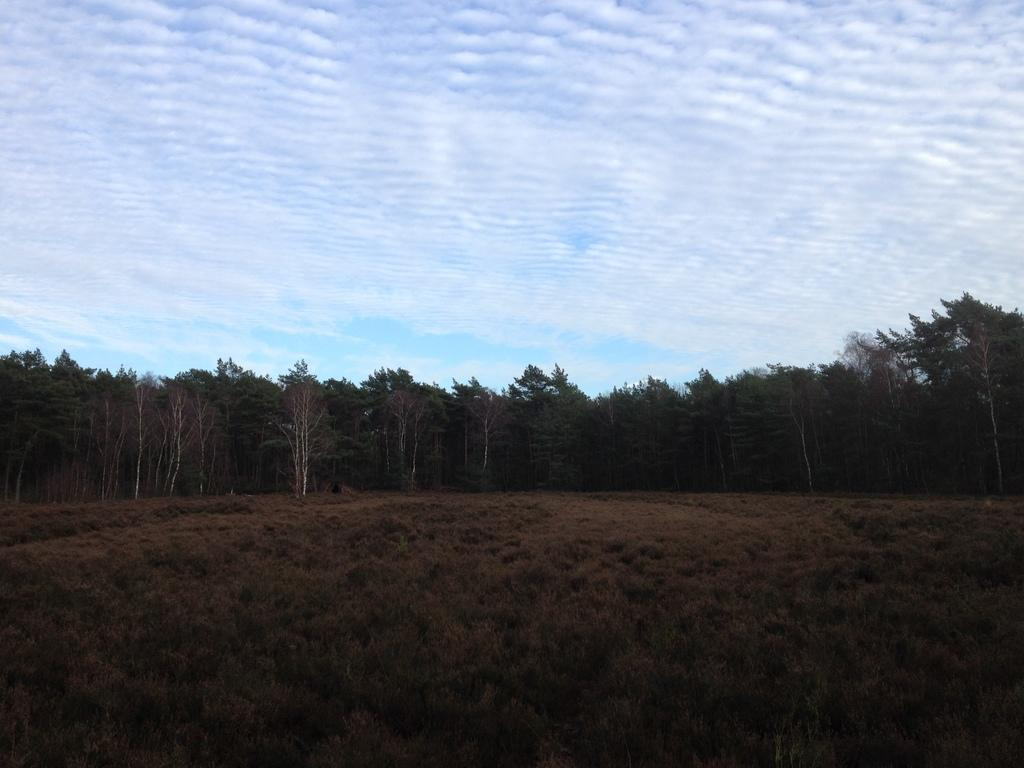What type of vegetation can be seen in the image? There is grass in the image. What is located in the middle of the image? There are trees in the middle of the image. What is visible at the top of the image? The sky is visible at the top of the image. What is the disgusting answer that the grandfather provides in the image? There is no grandfather or any dialogue present in the image, so it is not possible to answer that question. 